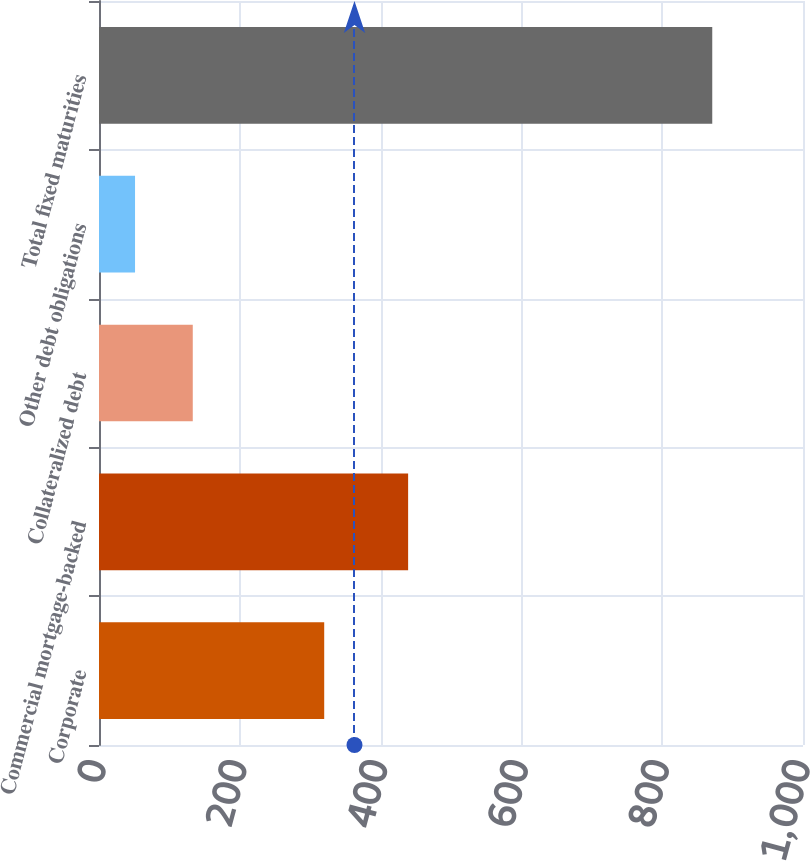<chart> <loc_0><loc_0><loc_500><loc_500><bar_chart><fcel>Corporate<fcel>Commercial mortgage-backed<fcel>Collateralized debt<fcel>Other debt obligations<fcel>Total fixed maturities<nl><fcel>319.9<fcel>439.1<fcel>133.19<fcel>51.2<fcel>871.1<nl></chart> 